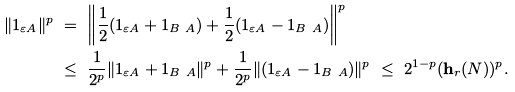<formula> <loc_0><loc_0><loc_500><loc_500>\| 1 _ { \varepsilon A } \| ^ { p } & \ = \ \left \| \frac { 1 } { 2 } ( 1 _ { \varepsilon A } + 1 _ { B \ A } ) + \frac { 1 } { 2 } ( 1 _ { \varepsilon A } - 1 _ { B \ A } ) \right \| ^ { p } \\ & \ \leq \ \frac { 1 } { 2 ^ { p } } \| 1 _ { \varepsilon A } + 1 _ { B \ A } \| ^ { p } + \frac { 1 } { 2 ^ { p } } \| ( 1 _ { \varepsilon A } - 1 _ { B \ A } ) \| ^ { p } \ \leq \ 2 ^ { 1 - p } ( \mathbf h _ { r } ( N ) ) ^ { p } .</formula> 